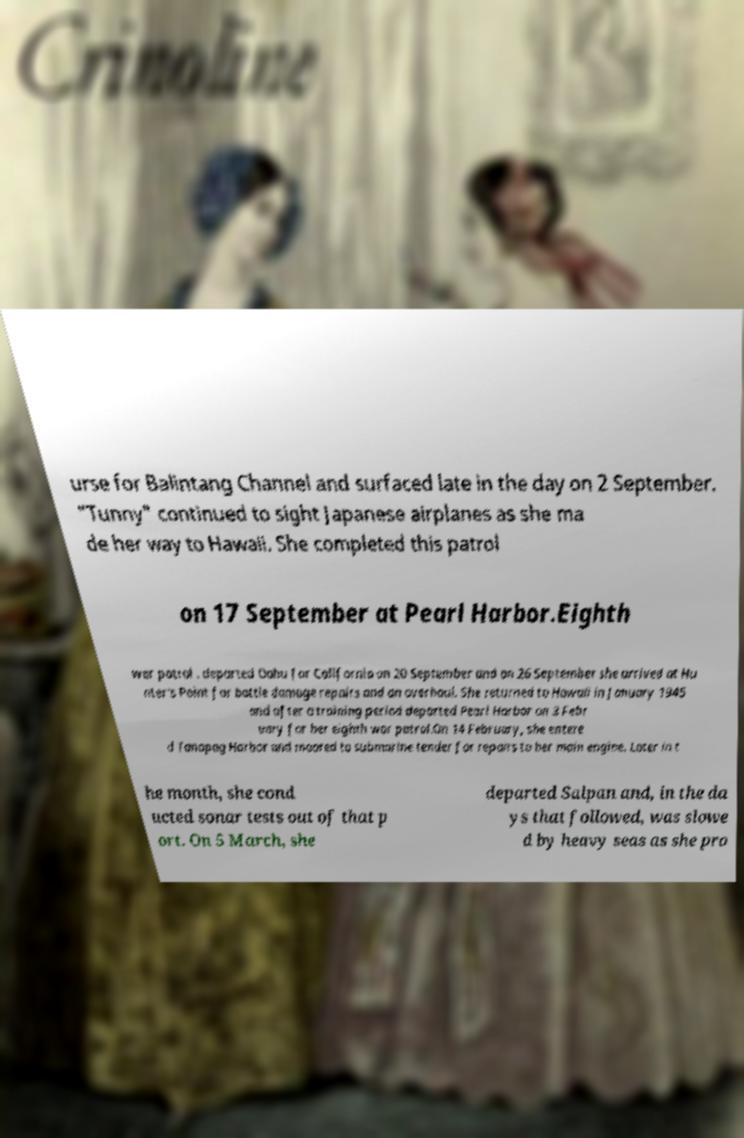I need the written content from this picture converted into text. Can you do that? urse for Balintang Channel and surfaced late in the day on 2 September. "Tunny" continued to sight Japanese airplanes as she ma de her way to Hawaii. She completed this patrol on 17 September at Pearl Harbor.Eighth war patrol . departed Oahu for California on 20 September and on 26 September she arrived at Hu nter's Point for battle damage repairs and an overhaul. She returned to Hawaii in January 1945 and after a training period departed Pearl Harbor on 3 Febr uary for her eighth war patrol.On 14 February, she entere d Tanapag Harbor and moored to submarine tender for repairs to her main engine. Later in t he month, she cond ucted sonar tests out of that p ort. On 5 March, she departed Saipan and, in the da ys that followed, was slowe d by heavy seas as she pro 